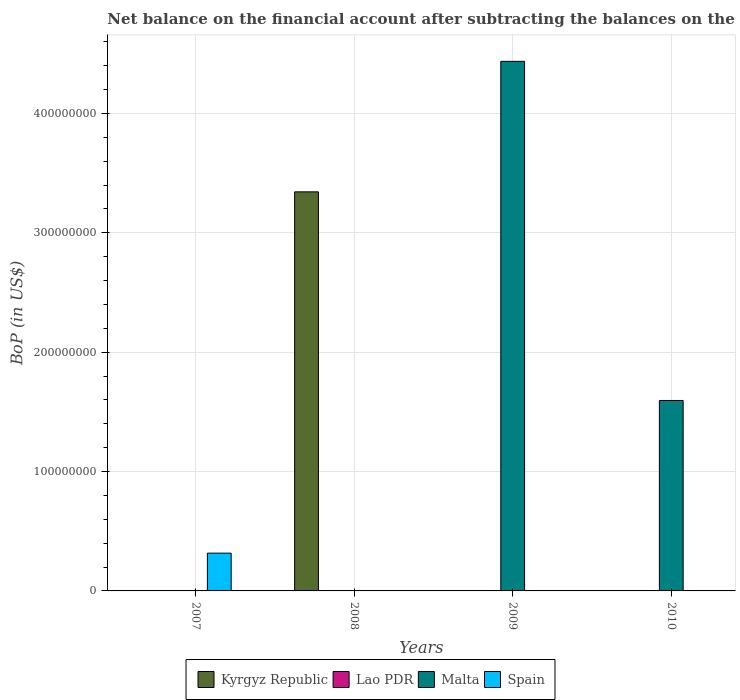How many different coloured bars are there?
Your answer should be compact. 3. Are the number of bars on each tick of the X-axis equal?
Your answer should be very brief. Yes. How many bars are there on the 1st tick from the left?
Your response must be concise. 1. How many bars are there on the 3rd tick from the right?
Your answer should be compact. 1. Across all years, what is the maximum Balance of Payments in Malta?
Give a very brief answer. 4.44e+08. Across all years, what is the minimum Balance of Payments in Lao PDR?
Offer a very short reply. 0. In which year was the Balance of Payments in Kyrgyz Republic maximum?
Keep it short and to the point. 2008. What is the total Balance of Payments in Malta in the graph?
Make the answer very short. 6.03e+08. What is the difference between the Balance of Payments in Malta in 2008 and the Balance of Payments in Spain in 2010?
Keep it short and to the point. 0. What is the average Balance of Payments in Malta per year?
Your answer should be very brief. 1.51e+08. In how many years, is the Balance of Payments in Malta greater than 200000000 US$?
Ensure brevity in your answer.  1. Is the Balance of Payments in Malta in 2009 less than that in 2010?
Ensure brevity in your answer.  No. What is the difference between the highest and the lowest Balance of Payments in Spain?
Provide a short and direct response. 3.16e+07. Is it the case that in every year, the sum of the Balance of Payments in Malta and Balance of Payments in Spain is greater than the Balance of Payments in Lao PDR?
Provide a short and direct response. No. Are all the bars in the graph horizontal?
Give a very brief answer. No. How many years are there in the graph?
Give a very brief answer. 4. What is the difference between two consecutive major ticks on the Y-axis?
Provide a succinct answer. 1.00e+08. Does the graph contain any zero values?
Make the answer very short. Yes. Where does the legend appear in the graph?
Provide a succinct answer. Bottom center. How many legend labels are there?
Provide a short and direct response. 4. What is the title of the graph?
Offer a terse response. Net balance on the financial account after subtracting the balances on the current accounts. Does "Moldova" appear as one of the legend labels in the graph?
Offer a very short reply. No. What is the label or title of the X-axis?
Keep it short and to the point. Years. What is the label or title of the Y-axis?
Offer a very short reply. BoP (in US$). What is the BoP (in US$) in Kyrgyz Republic in 2007?
Make the answer very short. 0. What is the BoP (in US$) of Spain in 2007?
Keep it short and to the point. 3.16e+07. What is the BoP (in US$) of Kyrgyz Republic in 2008?
Make the answer very short. 3.34e+08. What is the BoP (in US$) of Lao PDR in 2008?
Provide a succinct answer. 0. What is the BoP (in US$) of Kyrgyz Republic in 2009?
Provide a succinct answer. 0. What is the BoP (in US$) in Malta in 2009?
Give a very brief answer. 4.44e+08. What is the BoP (in US$) of Spain in 2009?
Your response must be concise. 0. What is the BoP (in US$) of Lao PDR in 2010?
Offer a terse response. 0. What is the BoP (in US$) in Malta in 2010?
Keep it short and to the point. 1.60e+08. What is the BoP (in US$) of Spain in 2010?
Give a very brief answer. 0. Across all years, what is the maximum BoP (in US$) of Kyrgyz Republic?
Make the answer very short. 3.34e+08. Across all years, what is the maximum BoP (in US$) in Malta?
Keep it short and to the point. 4.44e+08. Across all years, what is the maximum BoP (in US$) in Spain?
Keep it short and to the point. 3.16e+07. Across all years, what is the minimum BoP (in US$) in Kyrgyz Republic?
Ensure brevity in your answer.  0. What is the total BoP (in US$) in Kyrgyz Republic in the graph?
Your response must be concise. 3.34e+08. What is the total BoP (in US$) of Malta in the graph?
Offer a very short reply. 6.03e+08. What is the total BoP (in US$) in Spain in the graph?
Ensure brevity in your answer.  3.16e+07. What is the difference between the BoP (in US$) in Malta in 2009 and that in 2010?
Your answer should be compact. 2.84e+08. What is the difference between the BoP (in US$) of Kyrgyz Republic in 2008 and the BoP (in US$) of Malta in 2009?
Provide a succinct answer. -1.09e+08. What is the difference between the BoP (in US$) in Kyrgyz Republic in 2008 and the BoP (in US$) in Malta in 2010?
Offer a terse response. 1.75e+08. What is the average BoP (in US$) of Kyrgyz Republic per year?
Your response must be concise. 8.36e+07. What is the average BoP (in US$) in Malta per year?
Give a very brief answer. 1.51e+08. What is the average BoP (in US$) of Spain per year?
Make the answer very short. 7.91e+06. What is the ratio of the BoP (in US$) in Malta in 2009 to that in 2010?
Provide a short and direct response. 2.78. What is the difference between the highest and the lowest BoP (in US$) in Kyrgyz Republic?
Provide a short and direct response. 3.34e+08. What is the difference between the highest and the lowest BoP (in US$) of Malta?
Provide a short and direct response. 4.44e+08. What is the difference between the highest and the lowest BoP (in US$) in Spain?
Your answer should be compact. 3.16e+07. 